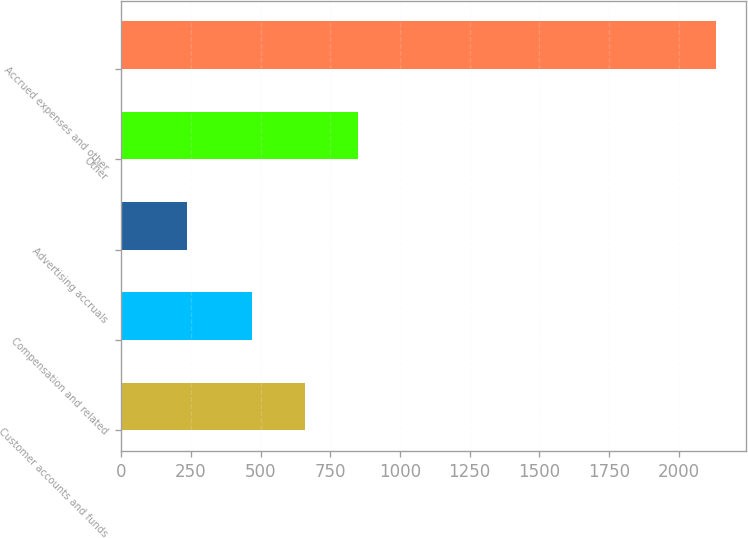Convert chart. <chart><loc_0><loc_0><loc_500><loc_500><bar_chart><fcel>Customer accounts and funds<fcel>Compensation and related<fcel>Advertising accruals<fcel>Other<fcel>Accrued expenses and other<nl><fcel>658.8<fcel>469<fcel>236<fcel>848.6<fcel>2134<nl></chart> 